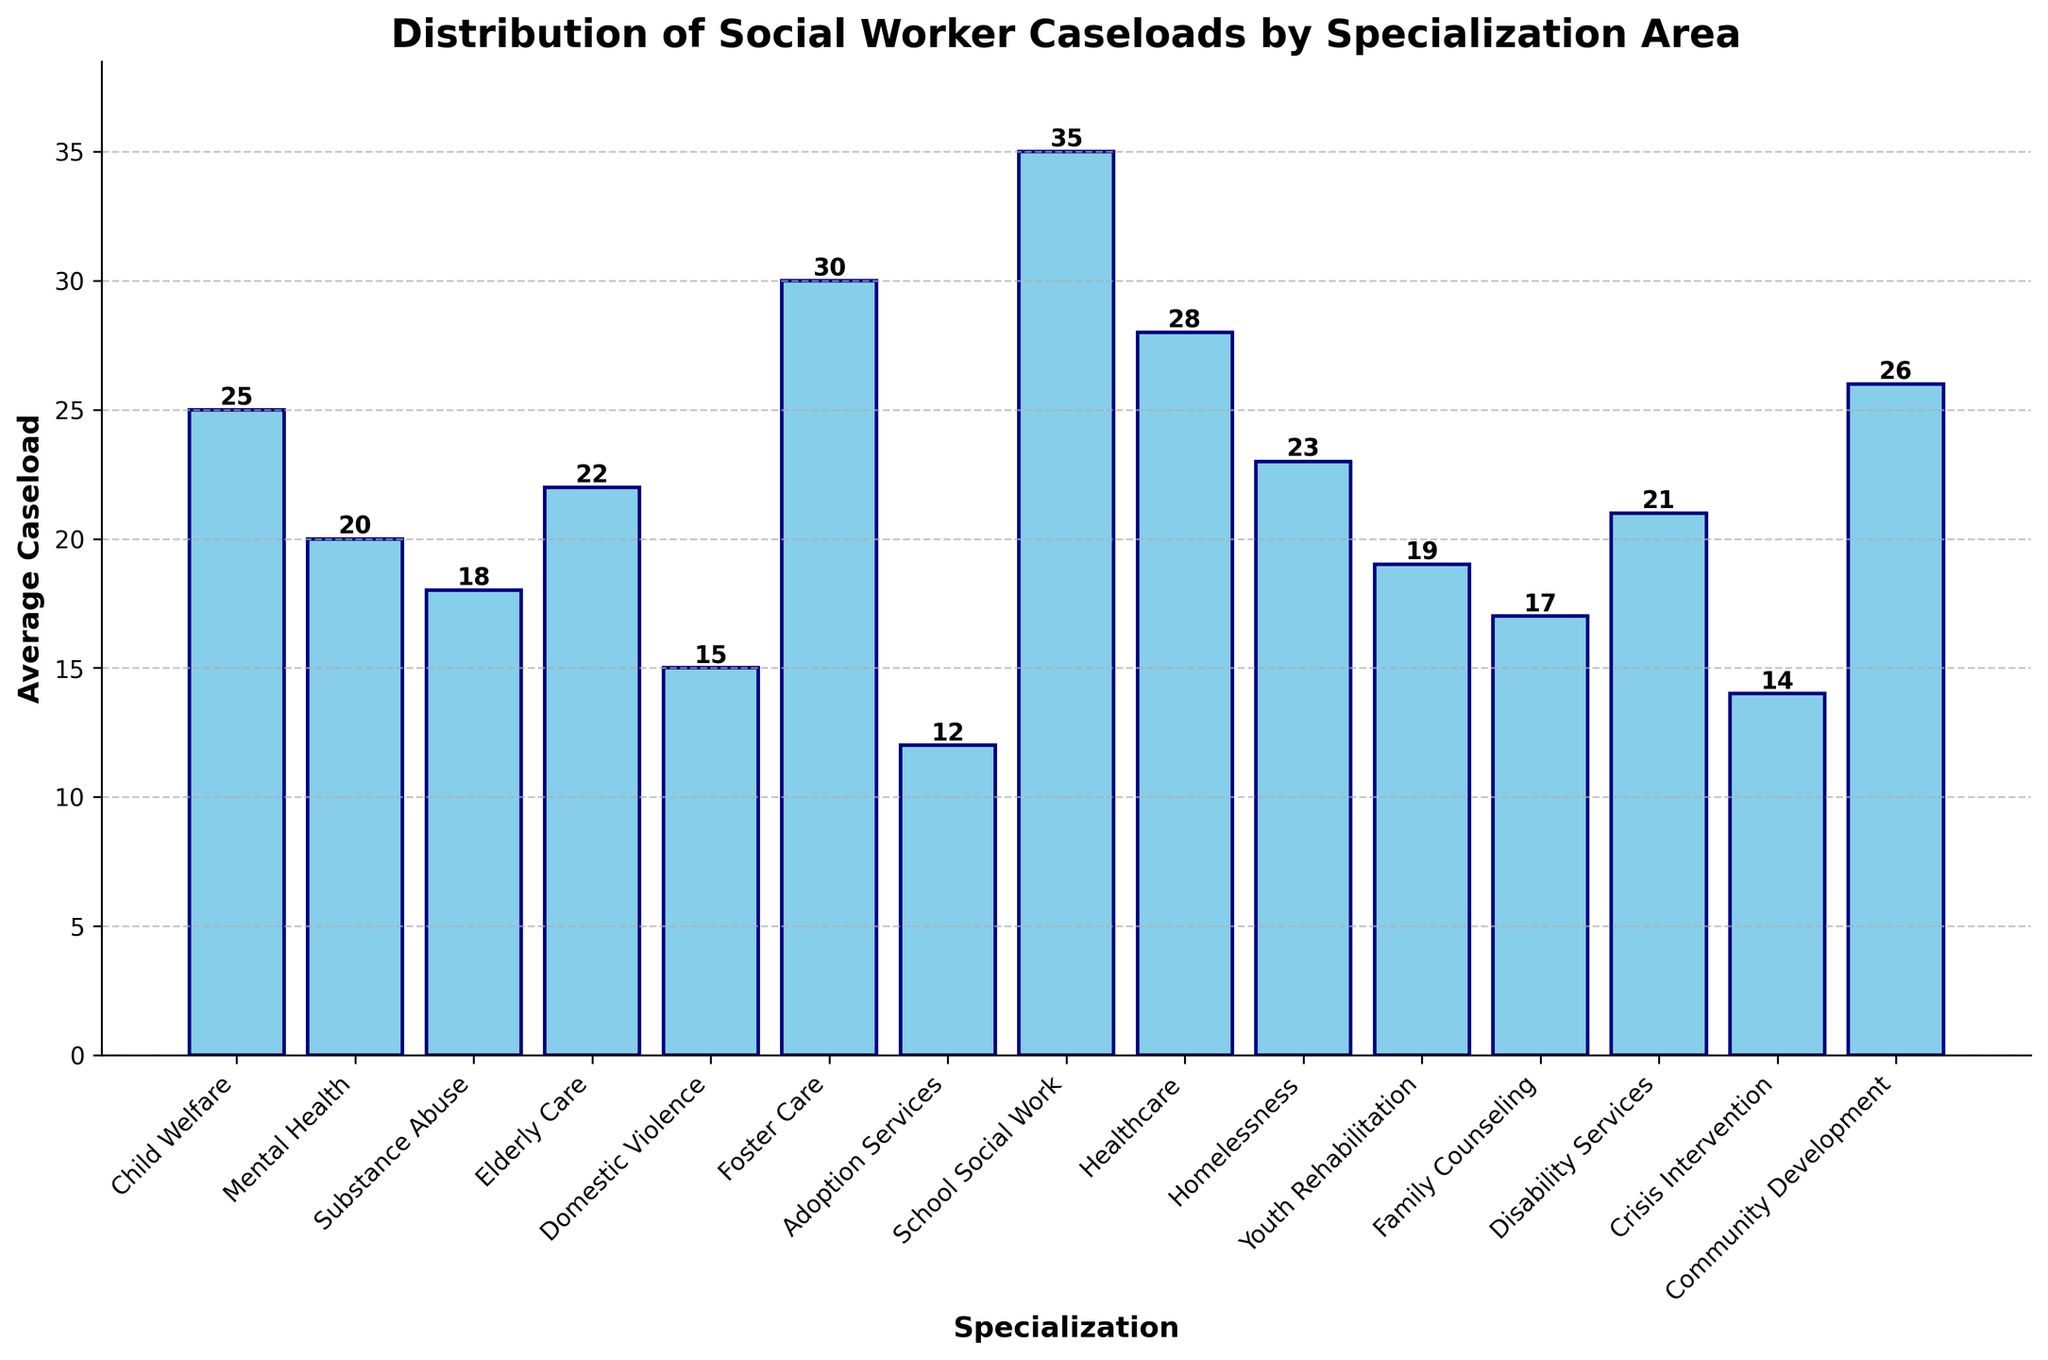What specialization has the highest average caseload? The specialization with the highest bar represents the highest average caseload. Looking at the figure, the tallest bar is for School Social Work.
Answer: School Social Work Which specialization has the lowest average caseload? The specialization with the shortest bar represents the lowest average caseload. The shortest bar corresponds to Adoption Services.
Answer: Adoption Services What is the difference between the average caseload of Healthcare and Elderly Care specializations? Identify the bars for Healthcare and Elderly Care. Healthcare has a value of 28, and Elderly Care has 22. Subtract the two values: 28 - 22.
Answer: 6 How many specializations have an average caseload above 20? Count the number of bars that are taller than the 20 marker on the y-axis. These specializations are Child Welfare, Elderly Care, Foster Care, School Social Work, Healthcare, Homelessness, and Community Development.
Answer: 7 Which specialization has a higher average caseload: Mental Health or Crisis Intervention? By how much? Identify the bars for Mental Health and Crisis Intervention. Mental Health has an average caseload of 20, while Crisis Intervention has 14. Subtract the smaller from the larger: 20 - 14.
Answer: Mental Health by 6 What is the combined average caseload of Substance Abuse, Family Counseling, and Disability Services? Find the bars for Substance Abuse, Family Counseling, and Disability Services. They have values of 18, 17, and 21 respectively. Sum these values: 18 + 17 + 21.
Answer: 56 Which two specializations have the closest average caseloads, and what are their values? Look for bars that have the smallest difference in heights. Community Development and Child Welfare have very close values with Community Development at 26 and Child Welfare at 25.
Answer: Community Development: 26, Child Welfare: 25 What is the average caseload for the three specializations with the lowest average caseloads? Identify the three shortest bars: Adoption Services, Crisis Intervention, and Domestic Violence. They have values of 12, 14, and 15, respectively. Calculate the average: (12 + 14 + 15) / 3.
Answer: 13.67 What colors are the bars in the chart? The colors of the bars can be described by their visual appearance. All the bars are colored sky blue with navy edges.
Answer: Sky blue with navy edges 